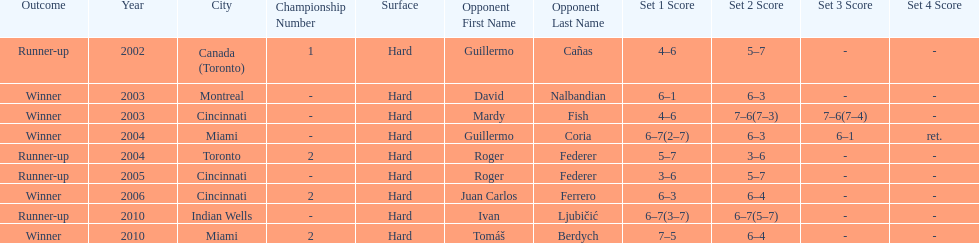How many times were roddick's opponents not from the usa? 8. 